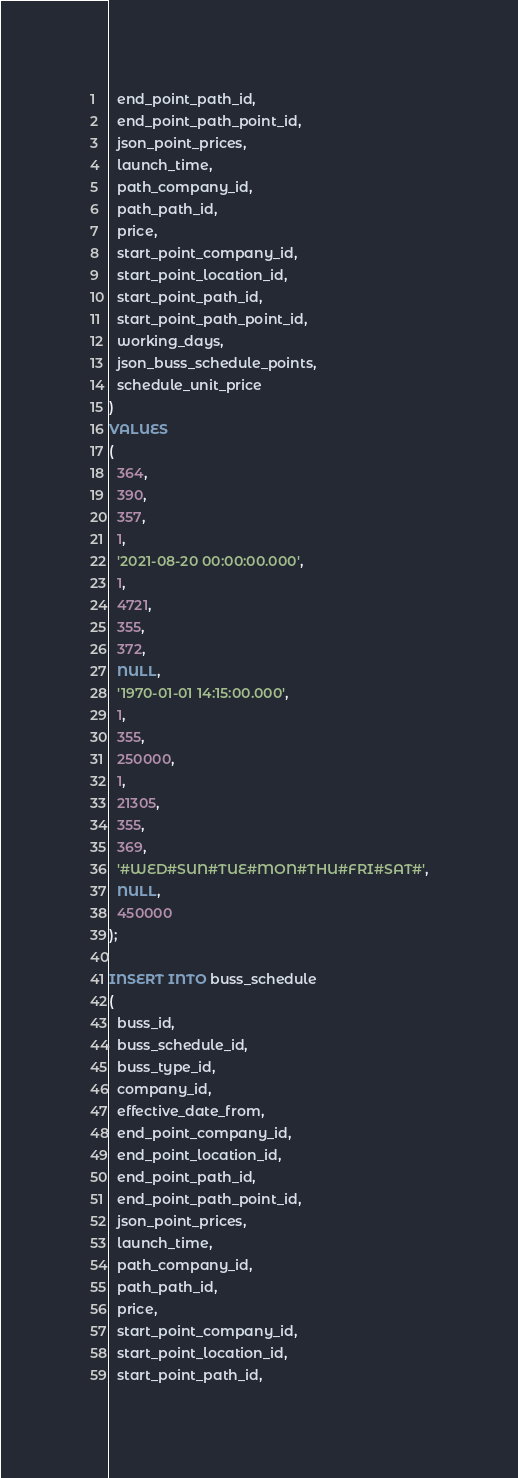<code> <loc_0><loc_0><loc_500><loc_500><_SQL_>  end_point_path_id,
  end_point_path_point_id,
  json_point_prices,
  launch_time,
  path_company_id,
  path_path_id,
  price,
  start_point_company_id,
  start_point_location_id,
  start_point_path_id,
  start_point_path_point_id,
  working_days,
  json_buss_schedule_points,
  schedule_unit_price
)
VALUES
(
  364,
  390,
  357,
  1,
  '2021-08-20 00:00:00.000',
  1,
  4721,
  355,
  372,
  NULL,
  '1970-01-01 14:15:00.000',
  1,
  355,
  250000,
  1,
  21305,
  355,
  369,
  '#WED#SUN#TUE#MON#THU#FRI#SAT#',
  NULL,
  450000
);

INSERT INTO buss_schedule
(
  buss_id,
  buss_schedule_id,
  buss_type_id,
  company_id,
  effective_date_from,
  end_point_company_id,
  end_point_location_id,
  end_point_path_id,
  end_point_path_point_id,
  json_point_prices,
  launch_time,
  path_company_id,
  path_path_id,
  price,
  start_point_company_id,
  start_point_location_id,
  start_point_path_id,</code> 